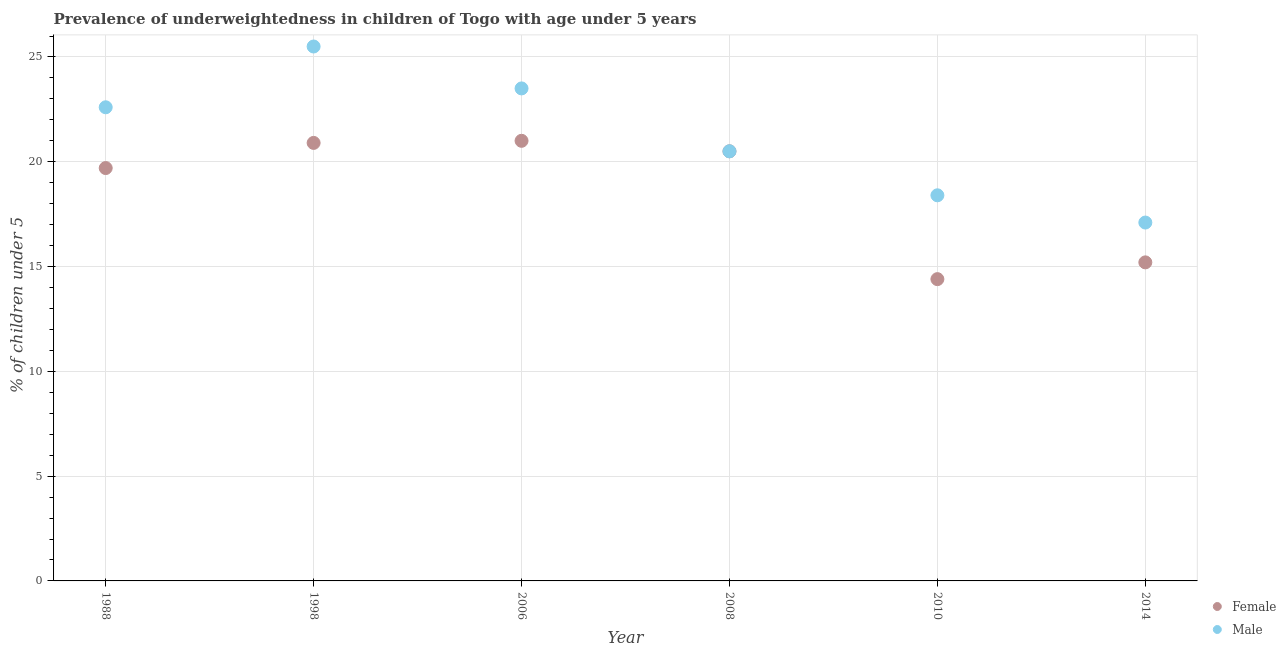How many different coloured dotlines are there?
Make the answer very short. 2. What is the percentage of underweighted male children in 1998?
Ensure brevity in your answer.  25.5. Across all years, what is the maximum percentage of underweighted male children?
Your response must be concise. 25.5. Across all years, what is the minimum percentage of underweighted male children?
Provide a succinct answer. 17.1. What is the total percentage of underweighted female children in the graph?
Your answer should be very brief. 111.7. What is the difference between the percentage of underweighted male children in 1988 and that in 2014?
Make the answer very short. 5.5. What is the average percentage of underweighted female children per year?
Make the answer very short. 18.62. In the year 2014, what is the difference between the percentage of underweighted female children and percentage of underweighted male children?
Your answer should be compact. -1.9. What is the ratio of the percentage of underweighted male children in 2008 to that in 2010?
Give a very brief answer. 1.11. Is the percentage of underweighted male children in 2006 less than that in 2010?
Offer a very short reply. No. What is the difference between the highest and the second highest percentage of underweighted male children?
Give a very brief answer. 2. What is the difference between the highest and the lowest percentage of underweighted female children?
Provide a succinct answer. 6.6. Is the sum of the percentage of underweighted male children in 1988 and 1998 greater than the maximum percentage of underweighted female children across all years?
Ensure brevity in your answer.  Yes. What is the difference between two consecutive major ticks on the Y-axis?
Your answer should be compact. 5. Does the graph contain any zero values?
Your response must be concise. No. Does the graph contain grids?
Give a very brief answer. Yes. Where does the legend appear in the graph?
Provide a succinct answer. Bottom right. How are the legend labels stacked?
Ensure brevity in your answer.  Vertical. What is the title of the graph?
Offer a very short reply. Prevalence of underweightedness in children of Togo with age under 5 years. What is the label or title of the Y-axis?
Offer a terse response.  % of children under 5. What is the  % of children under 5 in Female in 1988?
Your answer should be very brief. 19.7. What is the  % of children under 5 in Male in 1988?
Give a very brief answer. 22.6. What is the  % of children under 5 of Female in 1998?
Provide a short and direct response. 20.9. What is the  % of children under 5 in Male in 1998?
Offer a very short reply. 25.5. What is the  % of children under 5 of Female in 2008?
Provide a short and direct response. 20.5. What is the  % of children under 5 in Male in 2008?
Offer a terse response. 20.5. What is the  % of children under 5 of Female in 2010?
Your answer should be very brief. 14.4. What is the  % of children under 5 in Male in 2010?
Your answer should be compact. 18.4. What is the  % of children under 5 in Female in 2014?
Your answer should be compact. 15.2. What is the  % of children under 5 in Male in 2014?
Keep it short and to the point. 17.1. Across all years, what is the maximum  % of children under 5 in Male?
Provide a succinct answer. 25.5. Across all years, what is the minimum  % of children under 5 in Female?
Make the answer very short. 14.4. Across all years, what is the minimum  % of children under 5 in Male?
Your answer should be compact. 17.1. What is the total  % of children under 5 in Female in the graph?
Offer a very short reply. 111.7. What is the total  % of children under 5 of Male in the graph?
Make the answer very short. 127.6. What is the difference between the  % of children under 5 in Male in 1988 and that in 1998?
Provide a short and direct response. -2.9. What is the difference between the  % of children under 5 in Female in 1988 and that in 2006?
Offer a terse response. -1.3. What is the difference between the  % of children under 5 in Male in 1988 and that in 2008?
Your answer should be compact. 2.1. What is the difference between the  % of children under 5 of Female in 1988 and that in 2014?
Your answer should be very brief. 4.5. What is the difference between the  % of children under 5 of Female in 1998 and that in 2006?
Provide a short and direct response. -0.1. What is the difference between the  % of children under 5 in Male in 1998 and that in 2006?
Keep it short and to the point. 2. What is the difference between the  % of children under 5 of Female in 1998 and that in 2010?
Keep it short and to the point. 6.5. What is the difference between the  % of children under 5 in Male in 1998 and that in 2010?
Offer a terse response. 7.1. What is the difference between the  % of children under 5 in Female in 1998 and that in 2014?
Provide a short and direct response. 5.7. What is the difference between the  % of children under 5 in Female in 2006 and that in 2008?
Your answer should be very brief. 0.5. What is the difference between the  % of children under 5 in Male in 2006 and that in 2008?
Provide a short and direct response. 3. What is the difference between the  % of children under 5 in Male in 2006 and that in 2010?
Provide a succinct answer. 5.1. What is the difference between the  % of children under 5 in Female in 2006 and that in 2014?
Give a very brief answer. 5.8. What is the difference between the  % of children under 5 of Male in 2008 and that in 2010?
Keep it short and to the point. 2.1. What is the difference between the  % of children under 5 in Female in 2010 and that in 2014?
Your answer should be very brief. -0.8. What is the difference between the  % of children under 5 in Male in 2010 and that in 2014?
Give a very brief answer. 1.3. What is the difference between the  % of children under 5 in Female in 1988 and the  % of children under 5 in Male in 2006?
Provide a succinct answer. -3.8. What is the difference between the  % of children under 5 of Female in 1988 and the  % of children under 5 of Male in 2014?
Provide a short and direct response. 2.6. What is the difference between the  % of children under 5 in Female in 1998 and the  % of children under 5 in Male in 2008?
Your response must be concise. 0.4. What is the difference between the  % of children under 5 in Female in 1998 and the  % of children under 5 in Male in 2014?
Offer a terse response. 3.8. What is the difference between the  % of children under 5 in Female in 2006 and the  % of children under 5 in Male in 2010?
Keep it short and to the point. 2.6. What is the difference between the  % of children under 5 of Female in 2006 and the  % of children under 5 of Male in 2014?
Give a very brief answer. 3.9. What is the difference between the  % of children under 5 in Female in 2010 and the  % of children under 5 in Male in 2014?
Make the answer very short. -2.7. What is the average  % of children under 5 of Female per year?
Offer a very short reply. 18.62. What is the average  % of children under 5 in Male per year?
Give a very brief answer. 21.27. In the year 2006, what is the difference between the  % of children under 5 of Female and  % of children under 5 of Male?
Ensure brevity in your answer.  -2.5. What is the ratio of the  % of children under 5 in Female in 1988 to that in 1998?
Keep it short and to the point. 0.94. What is the ratio of the  % of children under 5 in Male in 1988 to that in 1998?
Offer a terse response. 0.89. What is the ratio of the  % of children under 5 in Female in 1988 to that in 2006?
Make the answer very short. 0.94. What is the ratio of the  % of children under 5 in Male in 1988 to that in 2006?
Your answer should be very brief. 0.96. What is the ratio of the  % of children under 5 of Male in 1988 to that in 2008?
Provide a short and direct response. 1.1. What is the ratio of the  % of children under 5 in Female in 1988 to that in 2010?
Provide a short and direct response. 1.37. What is the ratio of the  % of children under 5 in Male in 1988 to that in 2010?
Provide a short and direct response. 1.23. What is the ratio of the  % of children under 5 of Female in 1988 to that in 2014?
Provide a short and direct response. 1.3. What is the ratio of the  % of children under 5 of Male in 1988 to that in 2014?
Offer a terse response. 1.32. What is the ratio of the  % of children under 5 in Female in 1998 to that in 2006?
Keep it short and to the point. 1. What is the ratio of the  % of children under 5 in Male in 1998 to that in 2006?
Make the answer very short. 1.09. What is the ratio of the  % of children under 5 of Female in 1998 to that in 2008?
Provide a succinct answer. 1.02. What is the ratio of the  % of children under 5 in Male in 1998 to that in 2008?
Your answer should be compact. 1.24. What is the ratio of the  % of children under 5 in Female in 1998 to that in 2010?
Offer a very short reply. 1.45. What is the ratio of the  % of children under 5 of Male in 1998 to that in 2010?
Give a very brief answer. 1.39. What is the ratio of the  % of children under 5 in Female in 1998 to that in 2014?
Make the answer very short. 1.38. What is the ratio of the  % of children under 5 in Male in 1998 to that in 2014?
Keep it short and to the point. 1.49. What is the ratio of the  % of children under 5 in Female in 2006 to that in 2008?
Ensure brevity in your answer.  1.02. What is the ratio of the  % of children under 5 in Male in 2006 to that in 2008?
Offer a very short reply. 1.15. What is the ratio of the  % of children under 5 in Female in 2006 to that in 2010?
Your answer should be compact. 1.46. What is the ratio of the  % of children under 5 in Male in 2006 to that in 2010?
Keep it short and to the point. 1.28. What is the ratio of the  % of children under 5 of Female in 2006 to that in 2014?
Offer a very short reply. 1.38. What is the ratio of the  % of children under 5 of Male in 2006 to that in 2014?
Your answer should be very brief. 1.37. What is the ratio of the  % of children under 5 of Female in 2008 to that in 2010?
Ensure brevity in your answer.  1.42. What is the ratio of the  % of children under 5 of Male in 2008 to that in 2010?
Your response must be concise. 1.11. What is the ratio of the  % of children under 5 in Female in 2008 to that in 2014?
Keep it short and to the point. 1.35. What is the ratio of the  % of children under 5 in Male in 2008 to that in 2014?
Ensure brevity in your answer.  1.2. What is the ratio of the  % of children under 5 of Female in 2010 to that in 2014?
Your answer should be very brief. 0.95. What is the ratio of the  % of children under 5 in Male in 2010 to that in 2014?
Your response must be concise. 1.08. What is the difference between the highest and the lowest  % of children under 5 of Female?
Your response must be concise. 6.6. What is the difference between the highest and the lowest  % of children under 5 in Male?
Offer a very short reply. 8.4. 